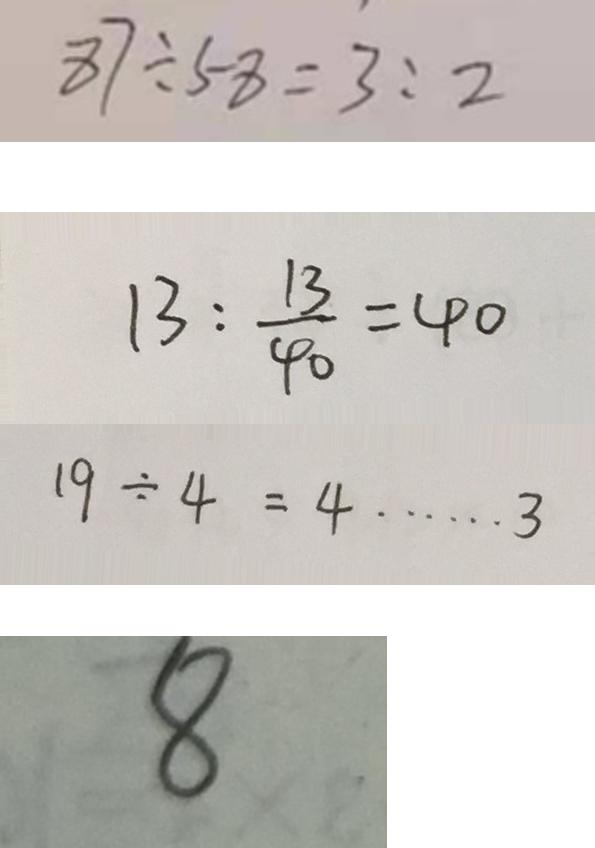<formula> <loc_0><loc_0><loc_500><loc_500>8 7 : 5 8 = 3 : 2 
 1 3 : \frac { 1 3 } { 4 0 } = 4 0 
 1 9 \div 4 = 4 \cdots 3 
 8</formula> 